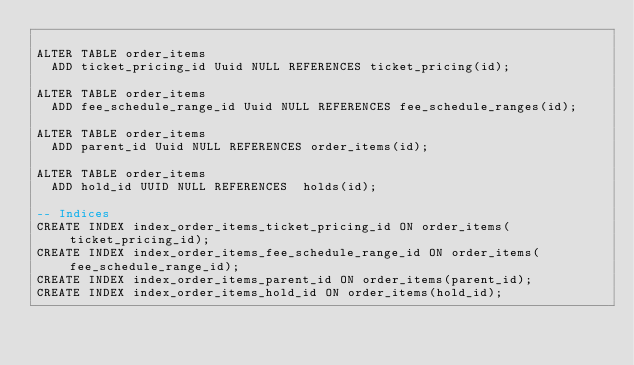Convert code to text. <code><loc_0><loc_0><loc_500><loc_500><_SQL_>
ALTER TABLE order_items
  ADD ticket_pricing_id Uuid NULL REFERENCES ticket_pricing(id);

ALTER TABLE order_items
  ADD fee_schedule_range_id Uuid NULL REFERENCES fee_schedule_ranges(id);

ALTER TABLE order_items
  ADD parent_id Uuid NULL REFERENCES order_items(id);

ALTER TABLE order_items
  ADD hold_id UUID NULL REFERENCES  holds(id);

-- Indices
CREATE INDEX index_order_items_ticket_pricing_id ON order_items(ticket_pricing_id);
CREATE INDEX index_order_items_fee_schedule_range_id ON order_items(fee_schedule_range_id);
CREATE INDEX index_order_items_parent_id ON order_items(parent_id);
CREATE INDEX index_order_items_hold_id ON order_items(hold_id);</code> 